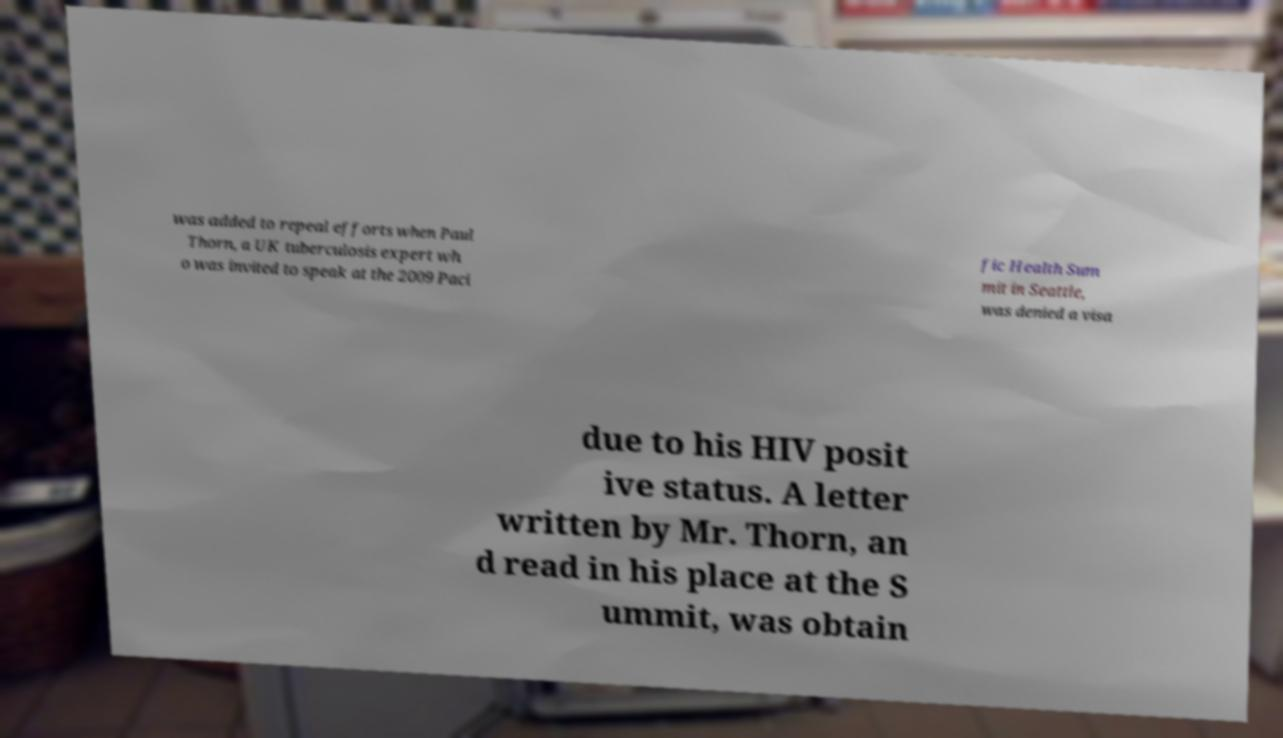For documentation purposes, I need the text within this image transcribed. Could you provide that? was added to repeal efforts when Paul Thorn, a UK tuberculosis expert wh o was invited to speak at the 2009 Paci fic Health Sum mit in Seattle, was denied a visa due to his HIV posit ive status. A letter written by Mr. Thorn, an d read in his place at the S ummit, was obtain 